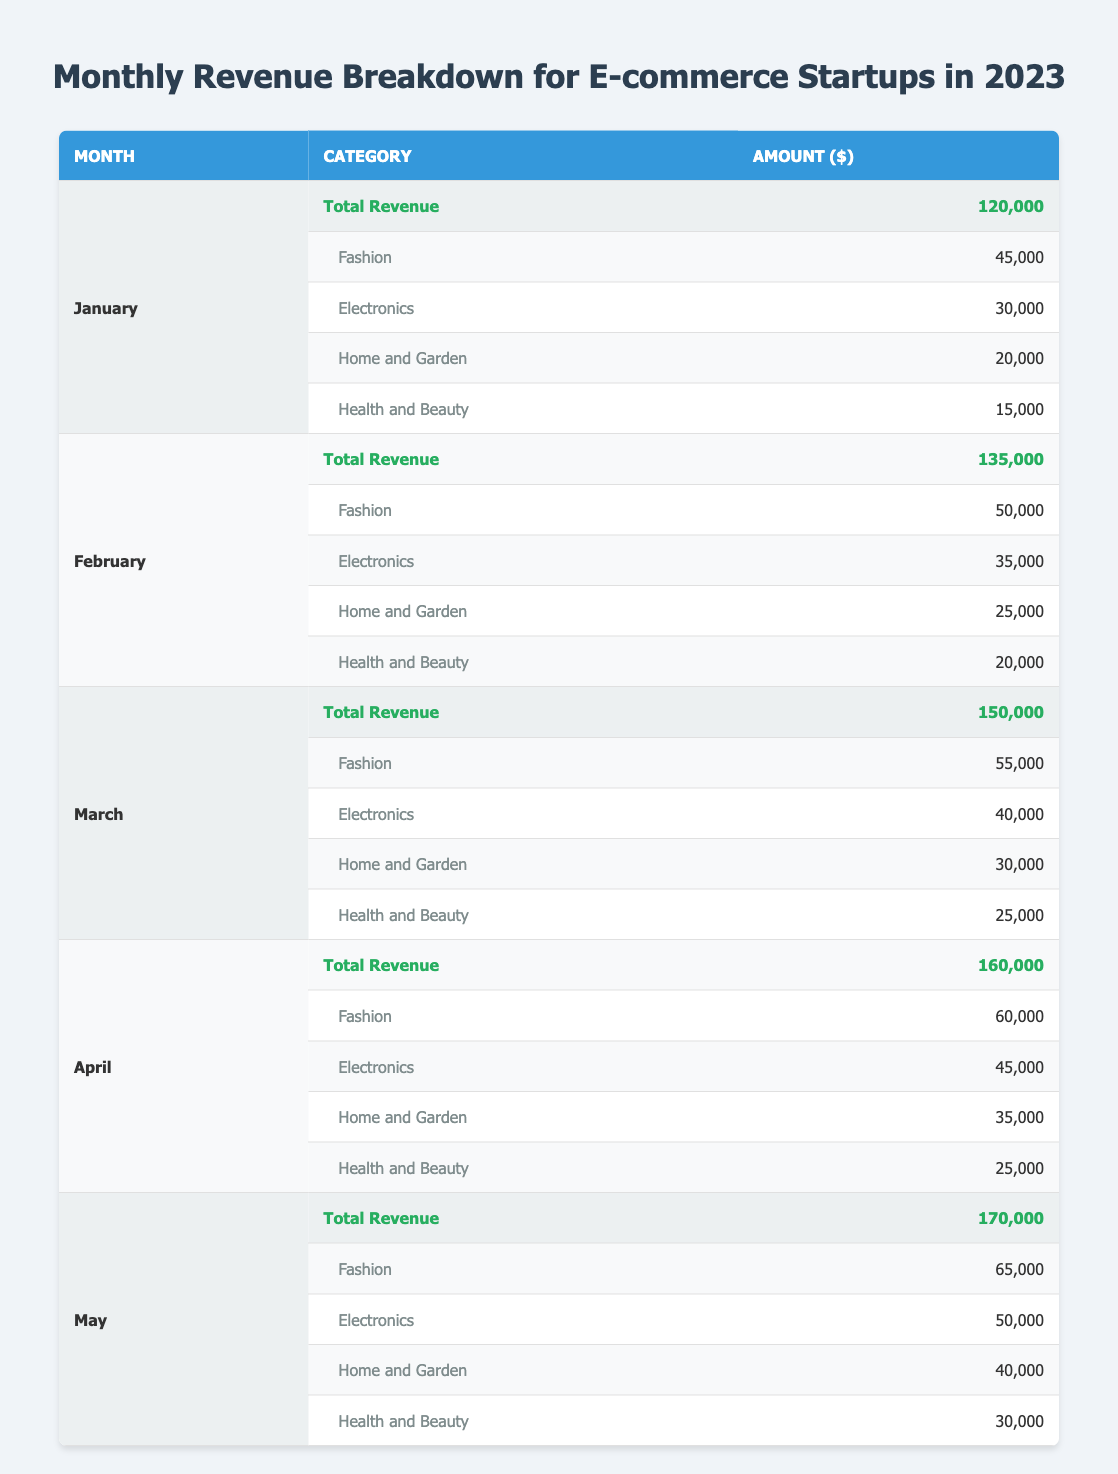What is the total revenue for March? The total revenue for March is listed directly in the table under the row for March, which shows a total revenue of 150,000.
Answer: 150,000 Which category generated the highest revenue in April? In April, the revenue breakdown shows that the Fashion category generated 60,000, which is more than the other categories (Electronics: 45,000, Home and Garden: 35,000, Health and Beauty: 25,000).
Answer: Fashion What is the average revenue from the Home and Garden category for the first five months? The Home and Garden revenues are 20,000 (Jan), 25,000 (Feb), 30,000 (Mar), 35,000 (Apr), and 40,000 (May). Summing these gives 20,000 + 25,000 + 30,000 + 35,000 + 40,000 = 150,000. The average is then 150,000 / 5 = 30,000.
Answer: 30,000 Did the revenue from the Electronics category increase from January to May? January has Electronics revenue at 30,000, and it increases to 50,000 in May. Since 50,000 is greater than 30,000, the answer is yes.
Answer: Yes What was the total revenue for the first quarter of 2023 (January to March)? The total revenue for the first quarter is the sum of the revenues for January (120,000), February (135,000), and March (150,000). Calculating gives 120,000 + 135,000 + 150,000 = 405,000.
Answer: 405,000 Which month had the least total revenue, and what was the amount? The month with the least total revenue is January with a total revenue of 120,000. This is found by comparing the total revenue of all five months.
Answer: January, 120,000 What is the difference in total revenue between May and February? The total revenue for May is 170,000 and for February is 135,000. The difference is calculated by subtracting February's revenue from May's: 170,000 - 135,000 = 35,000.
Answer: 35,000 Is it true that the revenue from the Health and Beauty category was consistently below 30,000 from January to May? Analyzing the Health and Beauty revenues shows that in January it's 15,000, February it's 20,000, March it's 25,000, April it's 25,000, and May it's 30,000. Since May is equal to 30,000, the claim is false.
Answer: No What is the total revenue for the Fashion category across the first five months? The revenues for Fashion are 45,000 (Jan), 50,000 (Feb), 55,000 (Mar), 60,000 (Apr), and 65,000 (May). Adding these gives 45,000 + 50,000 + 55,000 + 60,000 + 65,000 = 275,000.
Answer: 275,000 